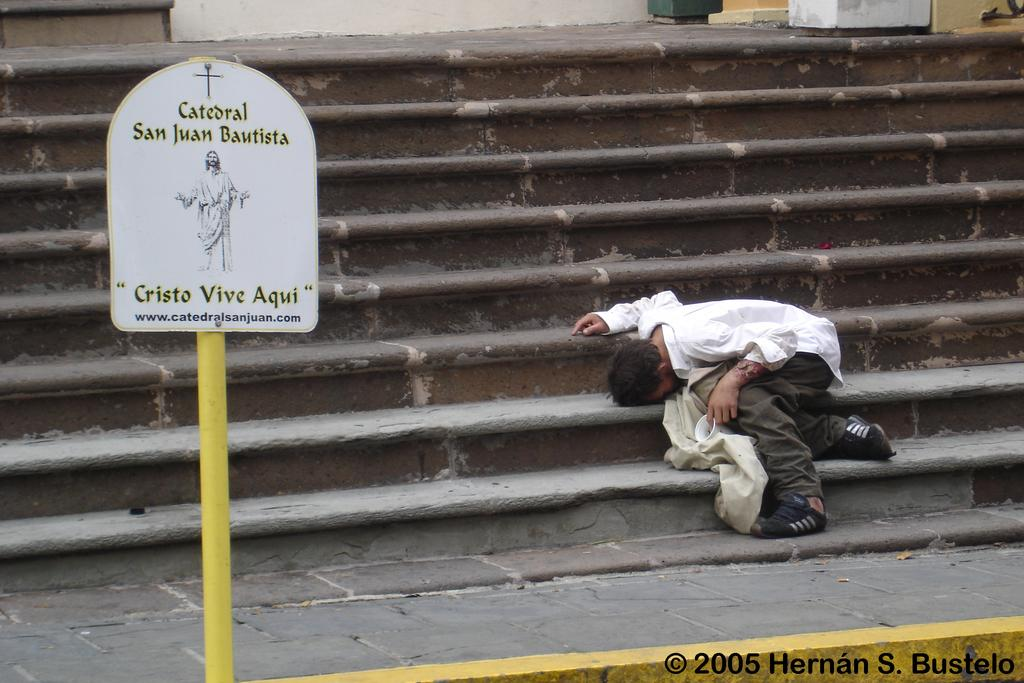What is the person in the image doing? The person is sitting on the staircases. What object is in front of the person? There is a board in front of the person. Is there any other object associated with the board? Yes, there is a pole associated with the board. What type of pickle is the person holding in the image? There is no pickle present in the image. What belief does the person have about the board and pole? The image does not provide any information about the person's beliefs, so we cannot answer this question. 